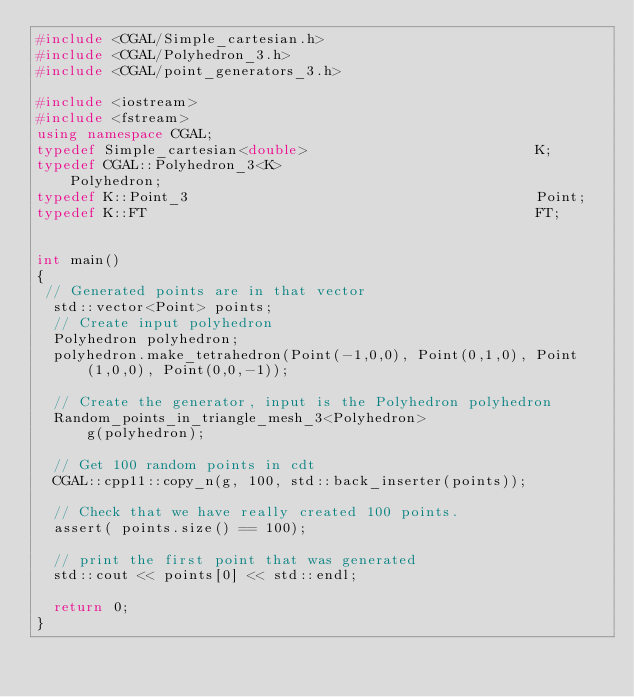Convert code to text. <code><loc_0><loc_0><loc_500><loc_500><_C++_>#include <CGAL/Simple_cartesian.h>
#include <CGAL/Polyhedron_3.h>
#include <CGAL/point_generators_3.h>

#include <iostream>
#include <fstream>
using namespace CGAL;
typedef Simple_cartesian<double>                           K;
typedef CGAL::Polyhedron_3<K>                              Polyhedron;
typedef K::Point_3                                         Point;
typedef K::FT                                              FT;


int main()
{
 // Generated points are in that vector
  std::vector<Point> points;
  // Create input polyhedron
  Polyhedron polyhedron;
  polyhedron.make_tetrahedron(Point(-1,0,0), Point(0,1,0), Point(1,0,0), Point(0,0,-1));

  // Create the generator, input is the Polyhedron polyhedron
  Random_points_in_triangle_mesh_3<Polyhedron>
      g(polyhedron);

  // Get 100 random points in cdt
  CGAL::cpp11::copy_n(g, 100, std::back_inserter(points));

  // Check that we have really created 100 points.
  assert( points.size() == 100);

  // print the first point that was generated
  std::cout << points[0] << std::endl;

  return 0;
}

</code> 